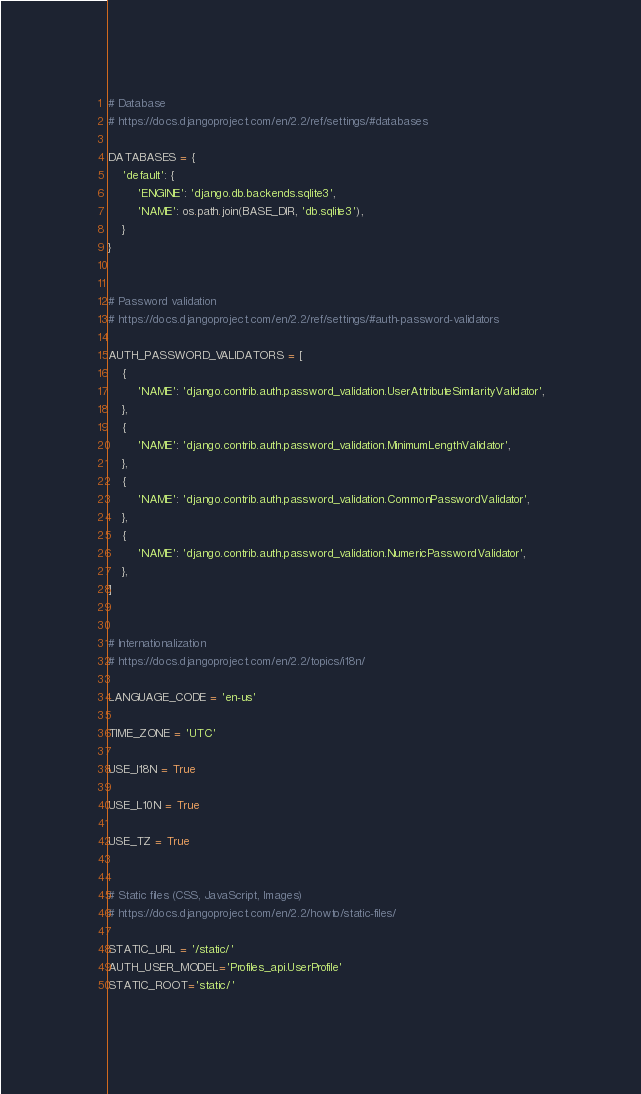<code> <loc_0><loc_0><loc_500><loc_500><_Python_>
# Database
# https://docs.djangoproject.com/en/2.2/ref/settings/#databases

DATABASES = {
    'default': {
        'ENGINE': 'django.db.backends.sqlite3',
        'NAME': os.path.join(BASE_DIR, 'db.sqlite3'),
    }
}


# Password validation
# https://docs.djangoproject.com/en/2.2/ref/settings/#auth-password-validators

AUTH_PASSWORD_VALIDATORS = [
    {
        'NAME': 'django.contrib.auth.password_validation.UserAttributeSimilarityValidator',
    },
    {
        'NAME': 'django.contrib.auth.password_validation.MinimumLengthValidator',
    },
    {
        'NAME': 'django.contrib.auth.password_validation.CommonPasswordValidator',
    },
    {
        'NAME': 'django.contrib.auth.password_validation.NumericPasswordValidator',
    },
]


# Internationalization
# https://docs.djangoproject.com/en/2.2/topics/i18n/

LANGUAGE_CODE = 'en-us'

TIME_ZONE = 'UTC'

USE_I18N = True

USE_L10N = True

USE_TZ = True


# Static files (CSS, JavaScript, Images)
# https://docs.djangoproject.com/en/2.2/howto/static-files/

STATIC_URL = '/static/'
AUTH_USER_MODEL='Profiles_api.UserProfile'
STATIC_ROOT='static/'
</code> 